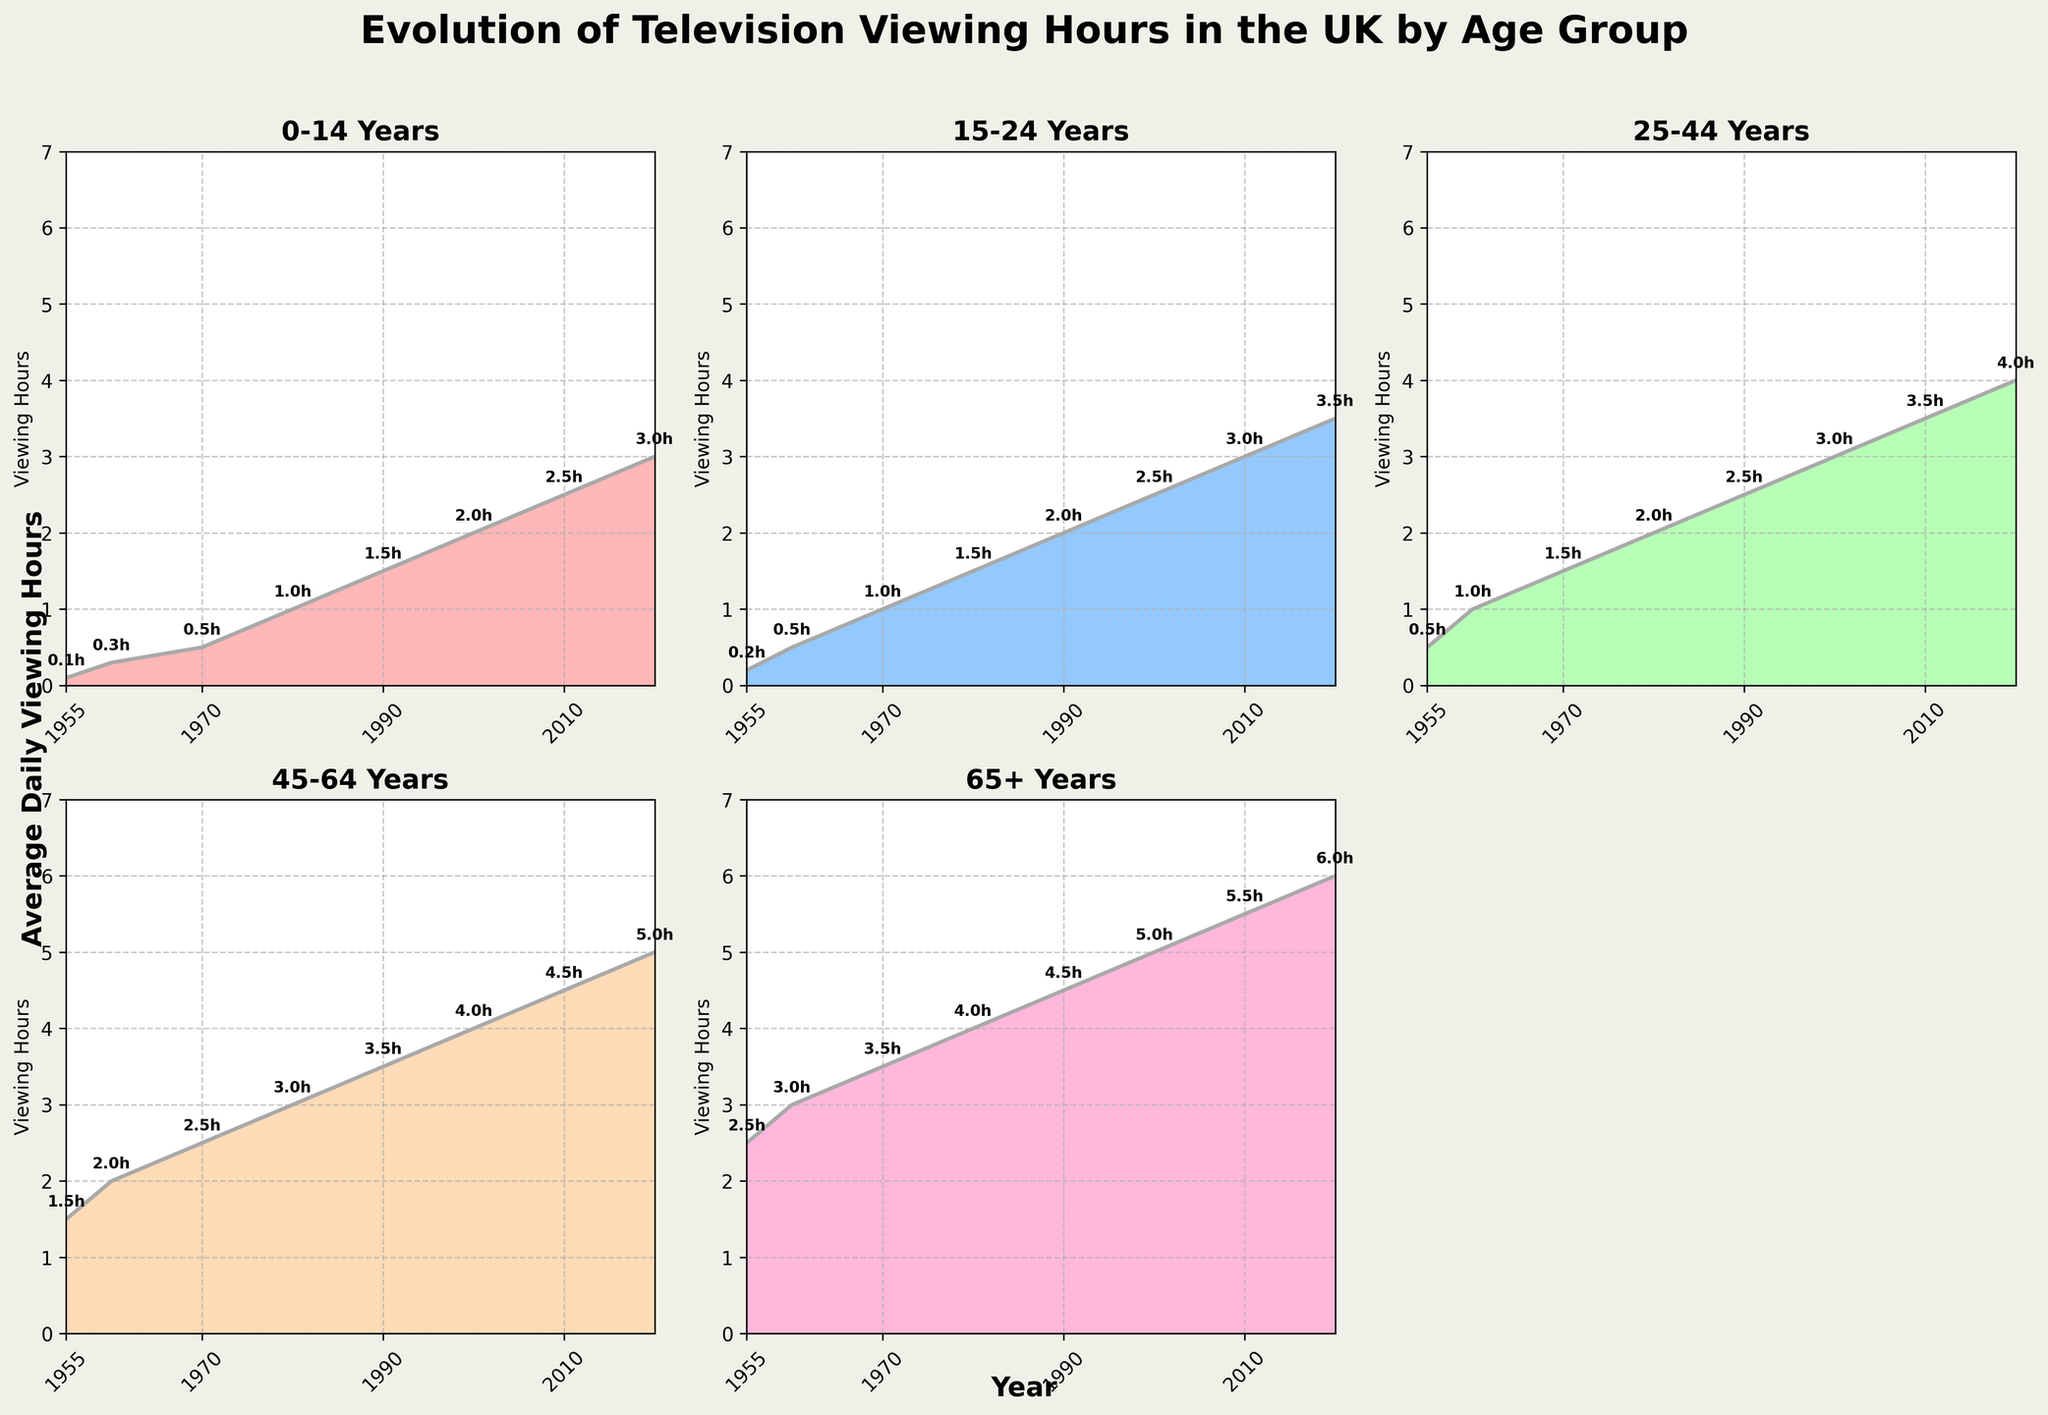What is the average daily viewing hours for the 0-14 Years age group in 1955? According to the plot for the 0-14 Years age group, the viewing hours in 1955 is shown as 0.1 hours.
Answer: 0.1 hours How many age groups are shown in the figure? The figure includes subplots for five different age groups: 0-14 Years, 15-24 Years, 25-44 Years, 45-64 Years, and 65+ Years.
Answer: Five Which age group showed the highest increase in viewing hours from 1955 to 2020? To determine which age group showed the highest increase, calculate the difference in viewing hours between 1955 and 2020 for each age group. The values are: 0-14 Years: 3.0 - 0.1 = 2.9, 15-24 Years: 3.5 - 0.2 = 3.3, 25-44 Years: 4.0 - 0.5 = 3.5, 45-64 Years: 5.0 - 1.5 = 3.5, 65+ Years: 6.0 - 2.5 = 3.5. The 45-64 Years, 25-44 Years, and 65+ Years groups all showed an increase of 3.5 hours, which is the highest increase.
Answer: 45-64 Years, 25-44 Years, 65+ Years What is the color used for the 15-24 Years age group? The subplot for the 15-24 Years age group is filled with a light blue color. A closer look shows it matches the second color in the list.
Answer: Light Blue What is the total viewing time across all age groups in the year 2020? Sum the viewing hours for all age groups in 2020: 0-14 Years: 3.0, 15-24 Years: 3.5, 25-44 Years: 4.0, 45-64 Years: 5.0, 65+ Years: 6.0. Calculating the sum: 3.0 + 3.5 + 4.0 + 5.0 + 6.0 = 21.5 hours.
Answer: 21.5 hours Which age group had consistent increment in viewing hours every decade? Identify the age group(s) which show a regular increment over each decade by inspecting each plot visually. The 25-44 Years age group shows this consistent trend over the decades from 1955 to 2020.
Answer: 25-44 Years By how much did the viewing hours for the 65+ Years age group increase between 1990 and 2000? Examine the subplot for the 65+ Years age group and note the viewing hours in 1990 and 2000. The values are 4.5 hours in 1990 and 5.0 hours in 2000. Calculate the increase: 5.0 - 4.5 = 0.5 hours.
Answer: 0.5 hours 